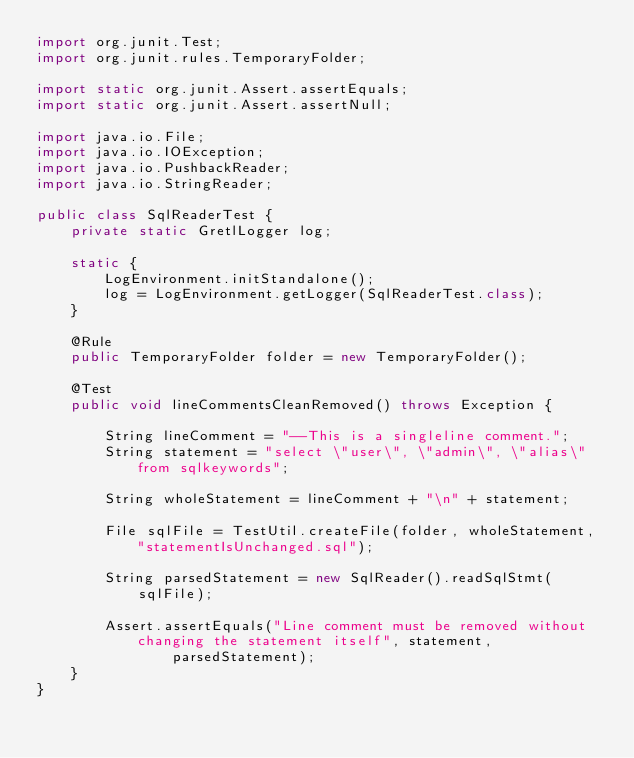<code> <loc_0><loc_0><loc_500><loc_500><_Java_>import org.junit.Test;
import org.junit.rules.TemporaryFolder;

import static org.junit.Assert.assertEquals;
import static org.junit.Assert.assertNull;

import java.io.File;
import java.io.IOException;
import java.io.PushbackReader;
import java.io.StringReader;

public class SqlReaderTest {
    private static GretlLogger log;

    static {
        LogEnvironment.initStandalone();
        log = LogEnvironment.getLogger(SqlReaderTest.class);
    }

    @Rule
    public TemporaryFolder folder = new TemporaryFolder();

    @Test
    public void lineCommentsCleanRemoved() throws Exception {

        String lineComment = "--This is a singleline comment.";
        String statement = "select \"user\", \"admin\", \"alias\" from sqlkeywords";

        String wholeStatement = lineComment + "\n" + statement;

        File sqlFile = TestUtil.createFile(folder, wholeStatement, "statementIsUnchanged.sql");

        String parsedStatement = new SqlReader().readSqlStmt(sqlFile);

        Assert.assertEquals("Line comment must be removed without changing the statement itself", statement,
                parsedStatement);
    }
}
</code> 